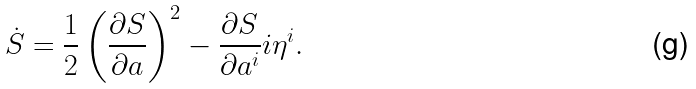<formula> <loc_0><loc_0><loc_500><loc_500>\dot { S } = \frac { 1 } { 2 } \left ( \frac { \partial S } { \partial a } \right ) ^ { 2 } - \frac { \partial S } { \partial a ^ { i } } i \eta ^ { i } .</formula> 